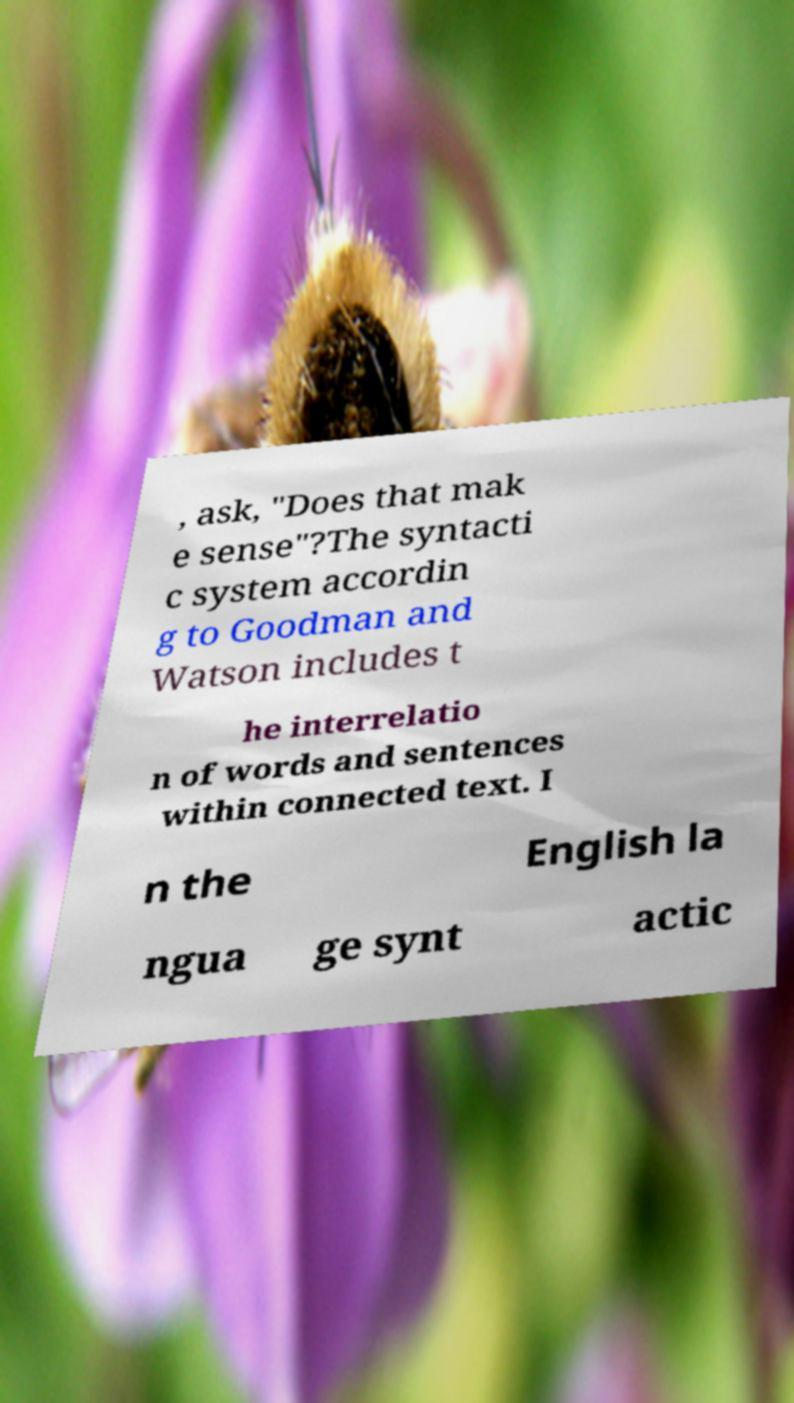Please identify and transcribe the text found in this image. , ask, "Does that mak e sense"?The syntacti c system accordin g to Goodman and Watson includes t he interrelatio n of words and sentences within connected text. I n the English la ngua ge synt actic 